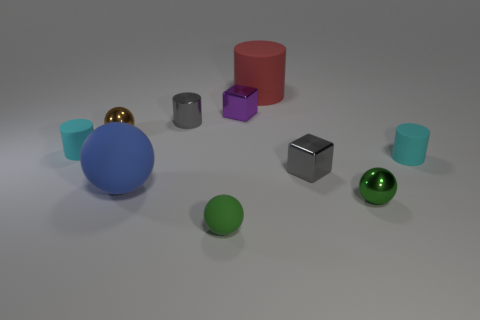Subtract 1 cylinders. How many cylinders are left? 3 Subtract all yellow cylinders. Subtract all gray balls. How many cylinders are left? 4 Subtract all cubes. How many objects are left? 8 Subtract all tiny spheres. Subtract all gray metallic things. How many objects are left? 5 Add 3 green metallic spheres. How many green metallic spheres are left? 4 Add 5 metallic cylinders. How many metallic cylinders exist? 6 Subtract 0 brown cylinders. How many objects are left? 10 